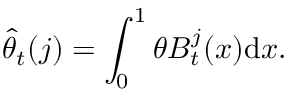<formula> <loc_0><loc_0><loc_500><loc_500>\widehat { \theta } _ { t } ( j ) = \int _ { 0 } ^ { 1 } \theta B _ { t } ^ { j } ( x ) { d } x .</formula> 